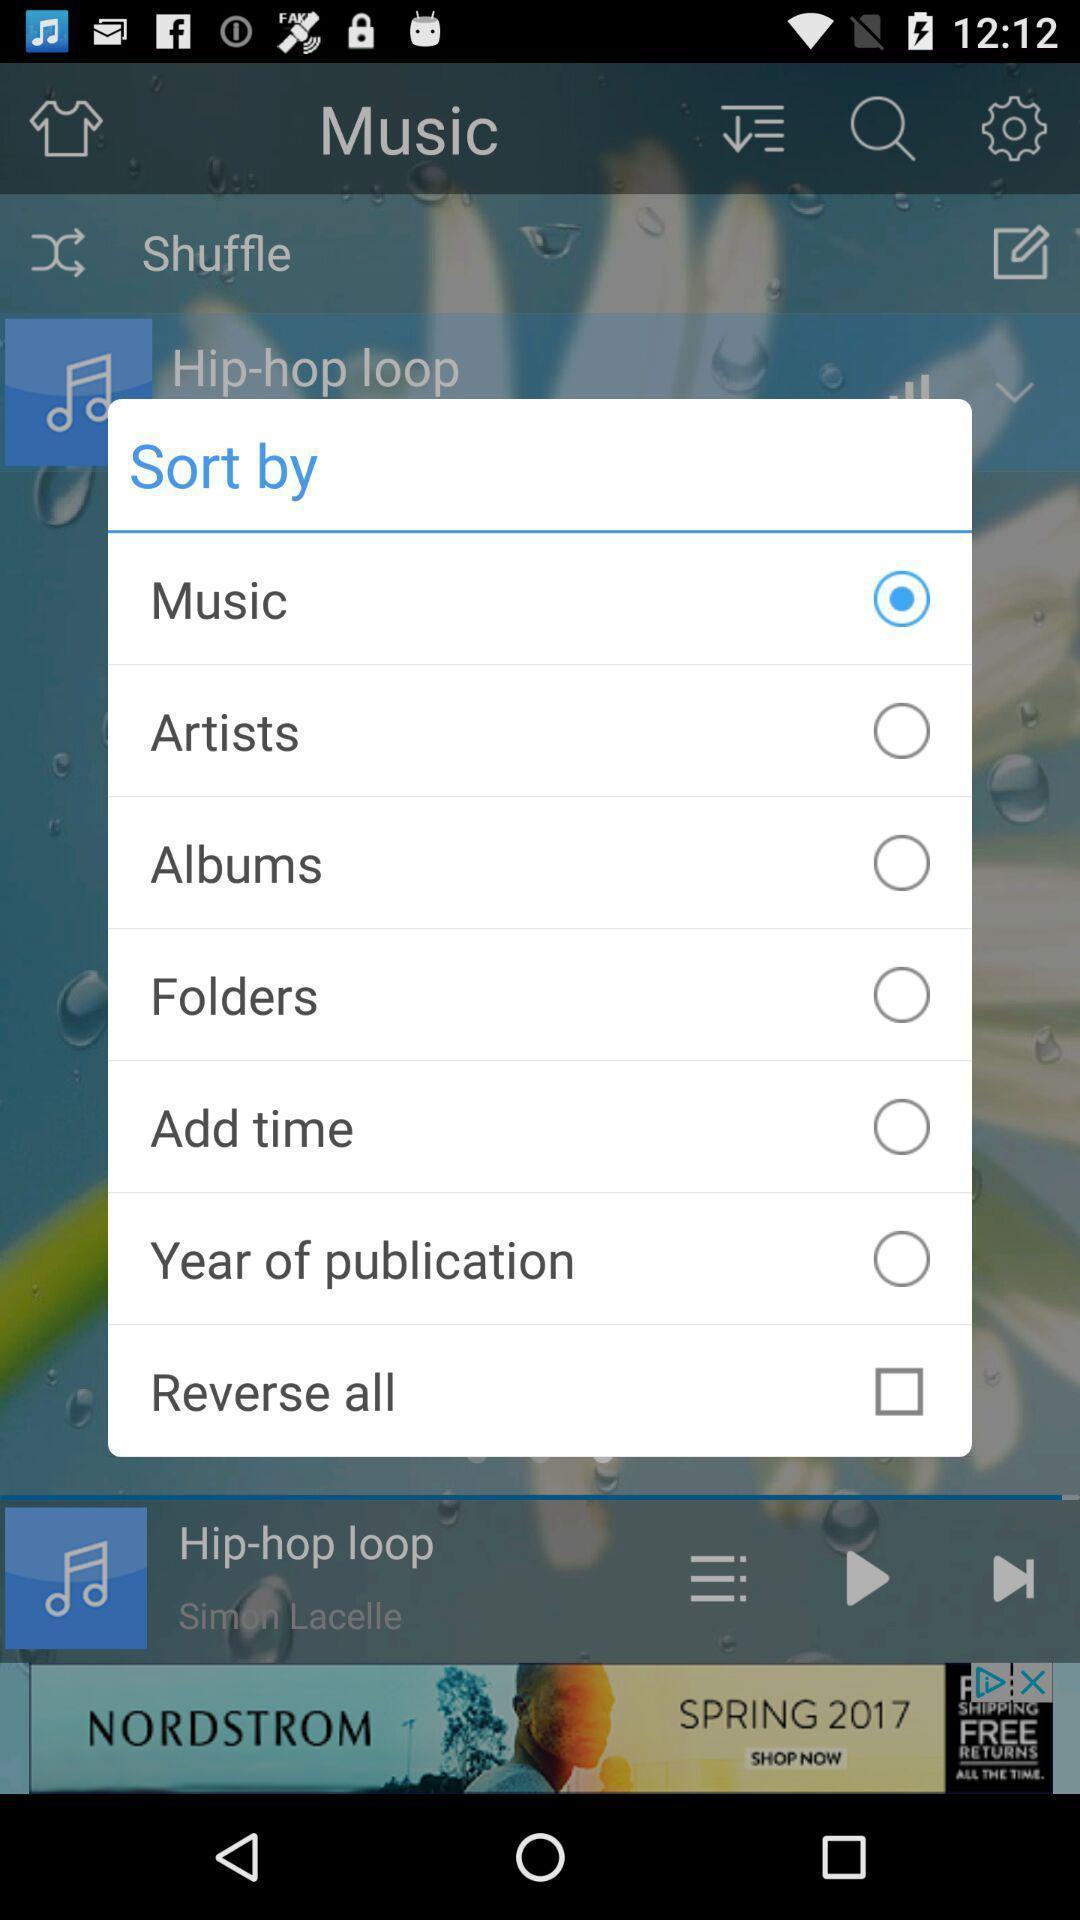Summarize the information in this screenshot. Popup showing some sorting options in a music app. 